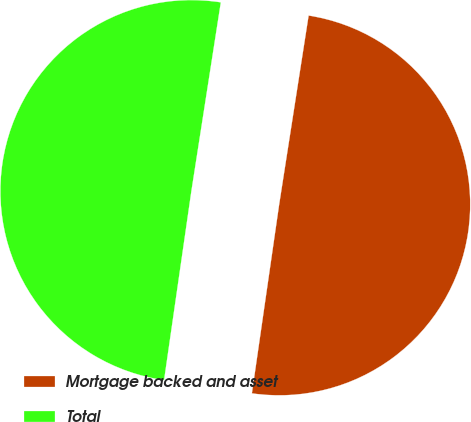<chart> <loc_0><loc_0><loc_500><loc_500><pie_chart><fcel>Mortgage backed and asset<fcel>Total<nl><fcel>49.82%<fcel>50.18%<nl></chart> 